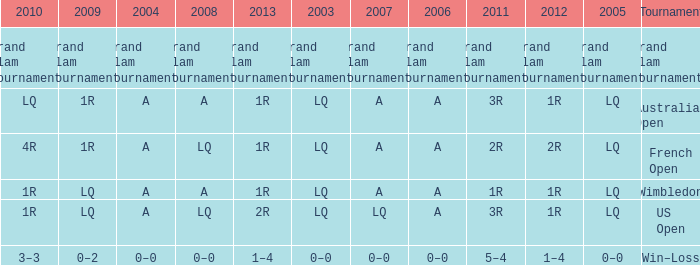Which year has a 2003 of lq? 1R, 1R, LQ, LQ. 